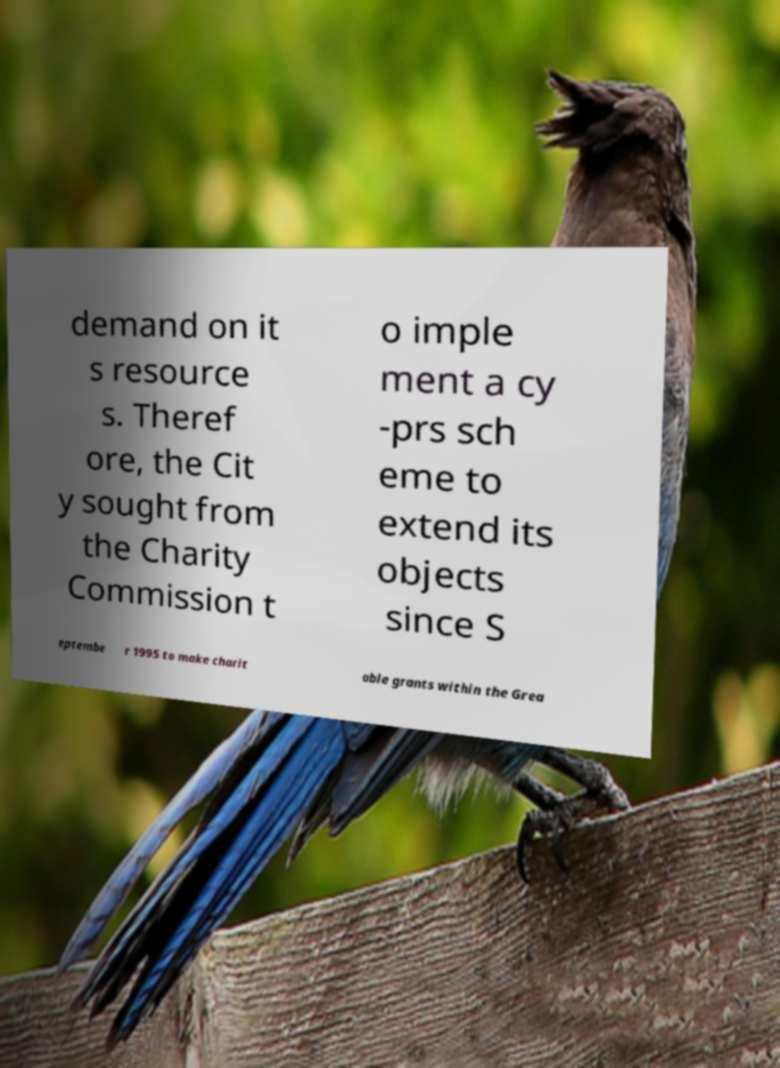I need the written content from this picture converted into text. Can you do that? demand on it s resource s. Theref ore, the Cit y sought from the Charity Commission t o imple ment a cy -prs sch eme to extend its objects since S eptembe r 1995 to make charit able grants within the Grea 